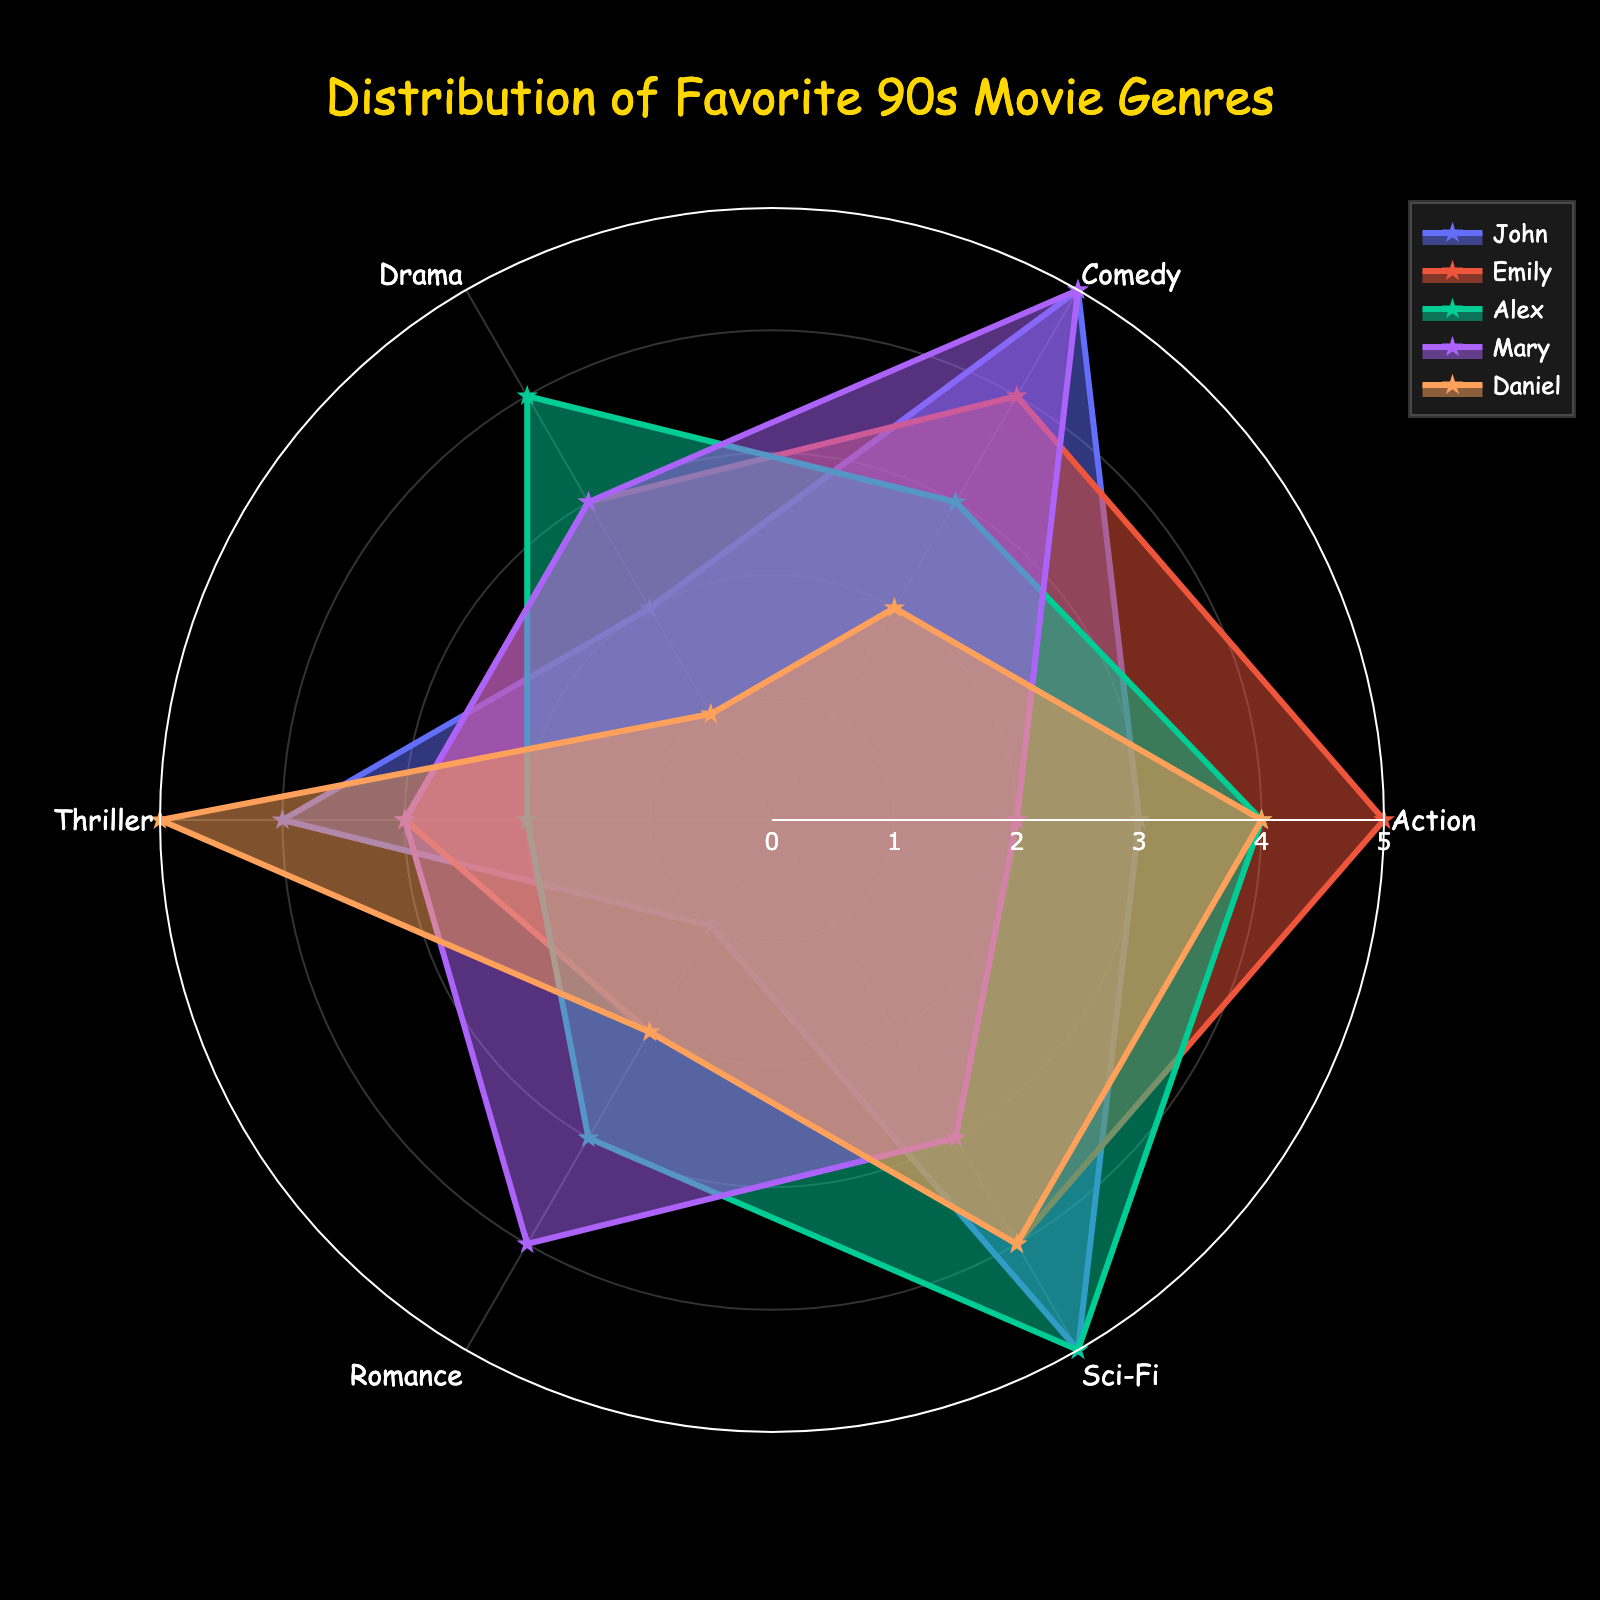What genre has the highest overall rating from all friends? To find the highest overall rating, compare the maximum values of the ratings for each genre across all friends. Sci-Fi has the maximum value of 5 from John, Alex, and Daniel.
Answer: Sci-Fi Who rated Romance the highest? Identify the friend with the highest rating in the Romance genre. Mary rated Romance the highest with a score of 4.
Answer: Mary What's the total score for the Comedy genre among our friends? Sum the values for Comedy across all friends. The scores are 5 (John) + 4 (Emily) + 3 (Alex) + 5 (Mary) + 2 (Daniel) = 19.
Answer: 19 Which genre is least liked by Daniel? Find the minimum value among Daniel's ratings and identify the corresponding genre. Daniel's lowest rating is 1, which corresponds to Drama.
Answer: Drama How many genres received a rating of 5 from at least one friend? Identify the genres with a rating of 5 from any friend. Action, Comedy, Sci-Fi, and Thriller have ratings of 5. So, there are 4 such genres.
Answer: 4 What’s the average rating given by Emily? Sum up Emily's ratings and divide by the number of genres. The ratings are 5 (Action) + 4 (Comedy) + 3 (Drama) + 3 (Thriller) + 2 (Romance) + 4 (Sci-Fi) = 21, divided by 6 genres = 3.5.
Answer: 3.5 Which friend's ratings show the most varied preferences based on the range? Calculate the range (max - min) of ratings for each friend and compare. Daniel's ratings range from 1 to 5, so his range is 4 (which is the highest).
Answer: Daniel Which genre has the smallest rating spread among friends? Calculate the spread for each genre (difference between max and min values). Romance has ratings from 1 to 4, so spread = 3, which is the smallest compared to others.
Answer: Romance Is there any genre that all friends rated at least a 3? Check each genre's ratings to see if all friends gave a rating of at least 3. Sci-Fi is rated 3 or higher by all friends.
Answer: Sci-Fi 